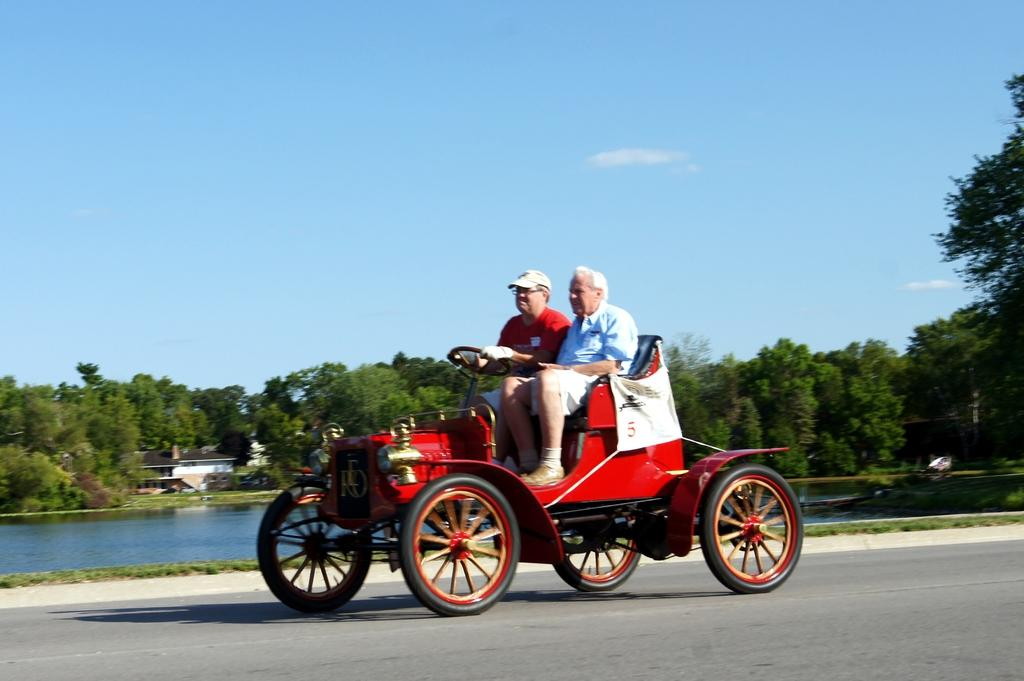How many people are in the image? There are two men in the image. What are the men doing in the image? The men are sitting on a vehicle and holding a steering wheel. What can be seen in the distance in the image? There are trees and a building with a roof top visible in the distance. What type of water body is depicted in the image? The image depicts a freshwater river. What type of quilt is being used to cover the truck in the image? There is no truck or quilt present in the image. How many rings are visible on the fingers of the men in the image? There is no information about rings on the men's fingers in the image. 